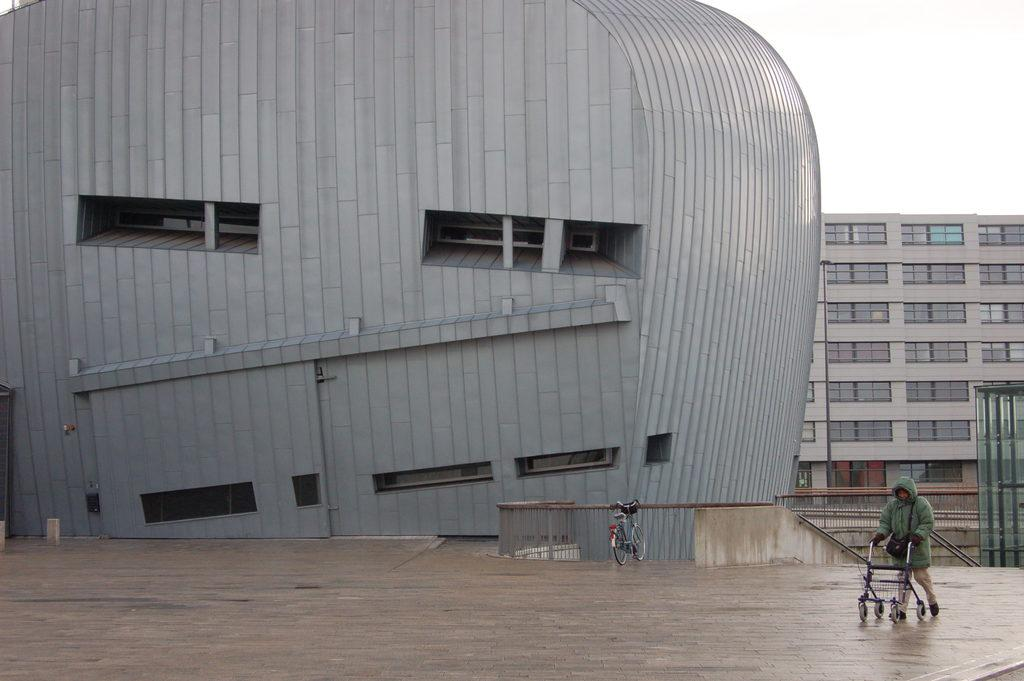What is the main subject of the image? The main subject of the image is the buildings at the center. Can you describe any other elements in the image? Yes, there is a person standing on the bottom right side of the image. What can be seen in the background of the image? The sky is visible in the background of the image. What type of music is the person playing on the bottom right side of the image? There is no indication in the image that the person is playing any music. 